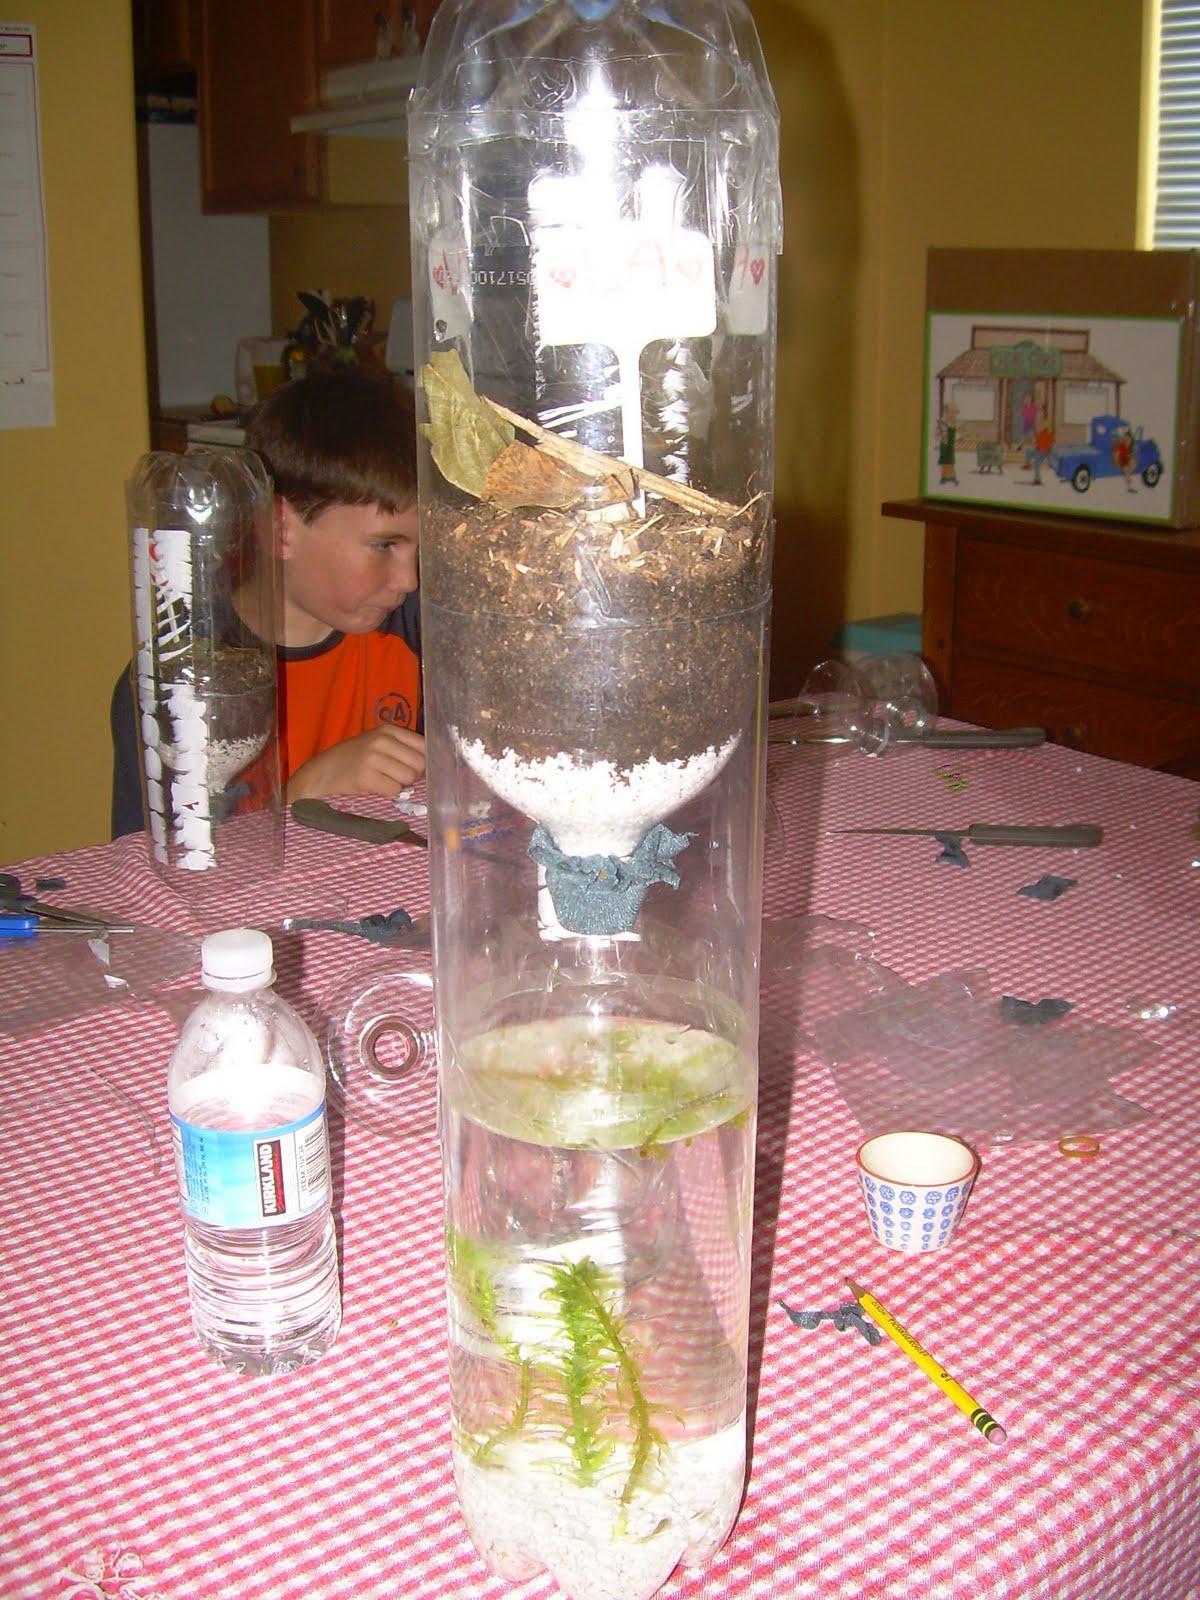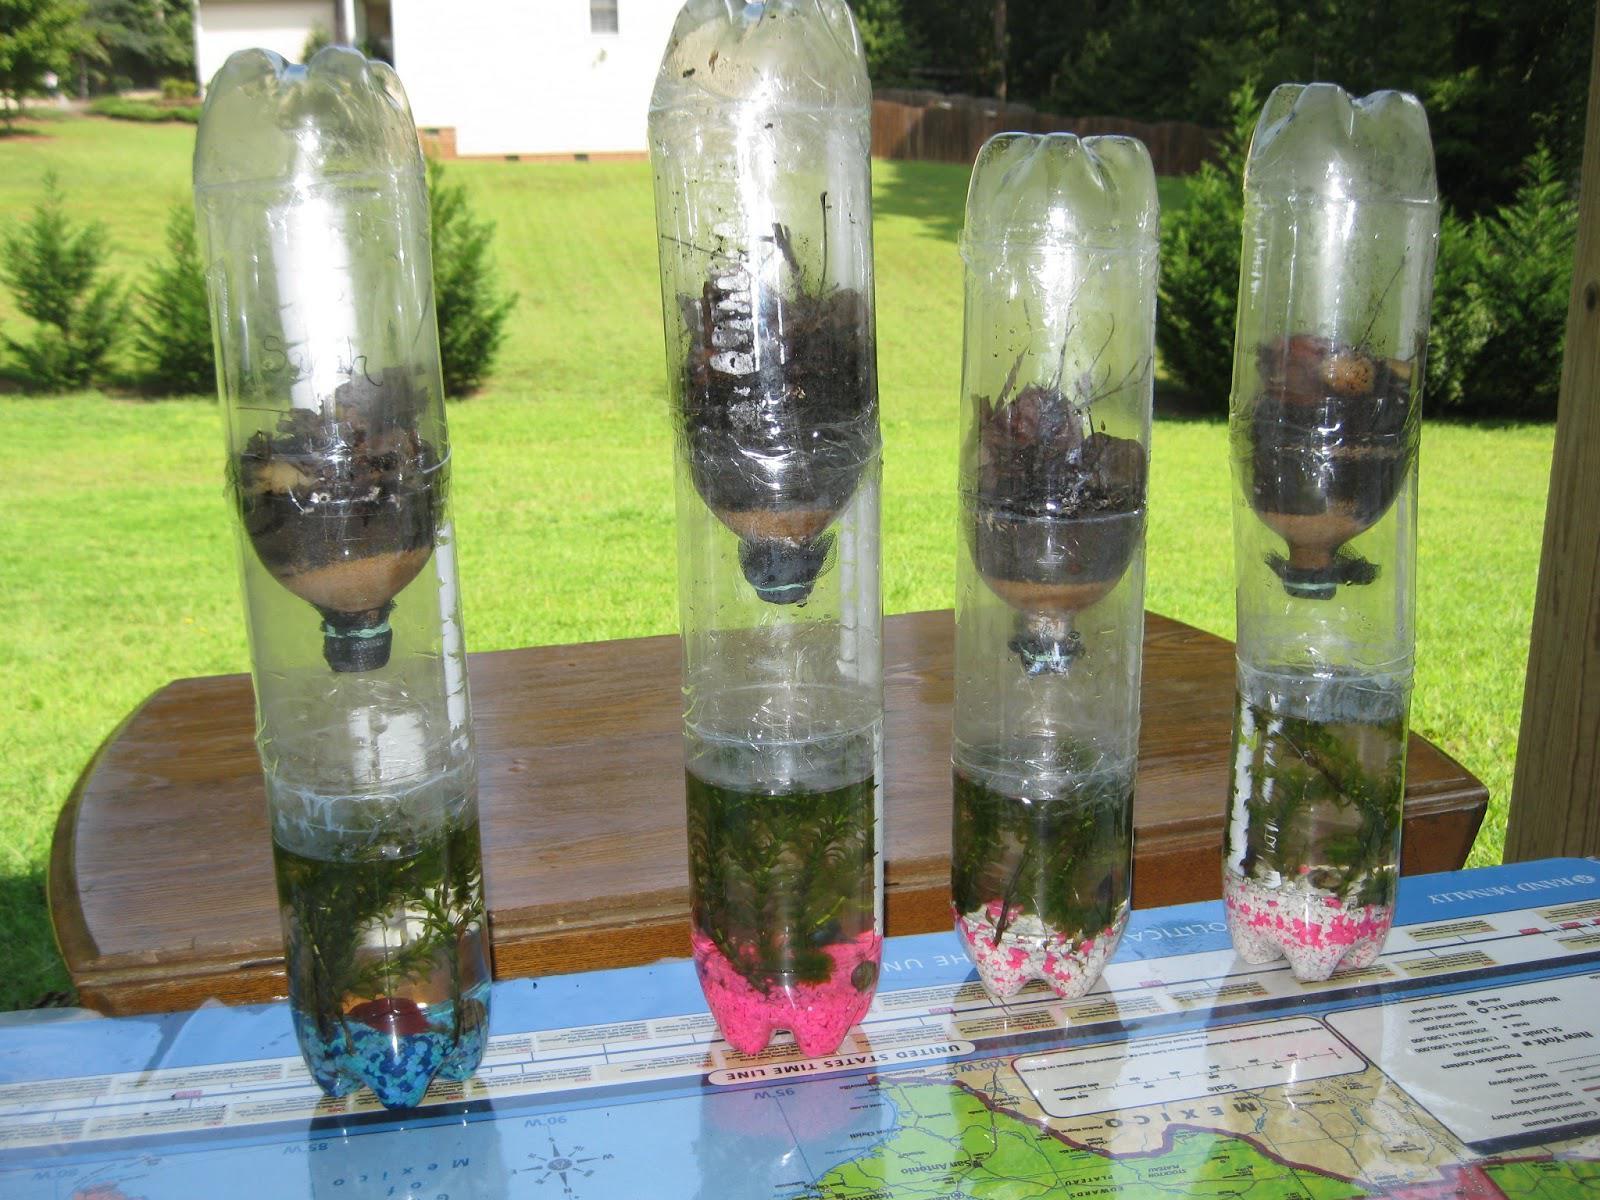The first image is the image on the left, the second image is the image on the right. Assess this claim about the two images: "There are more bottles in the image on the left.". Correct or not? Answer yes or no. No. The first image is the image on the left, the second image is the image on the right. For the images displayed, is the sentence "The combined images contain four bottle displays with green plants in them." factually correct? Answer yes or no. No. 